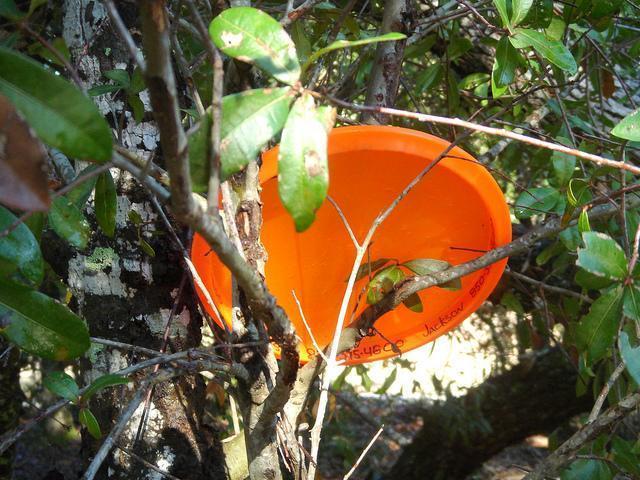How many bowls can you see?
Give a very brief answer. 1. 